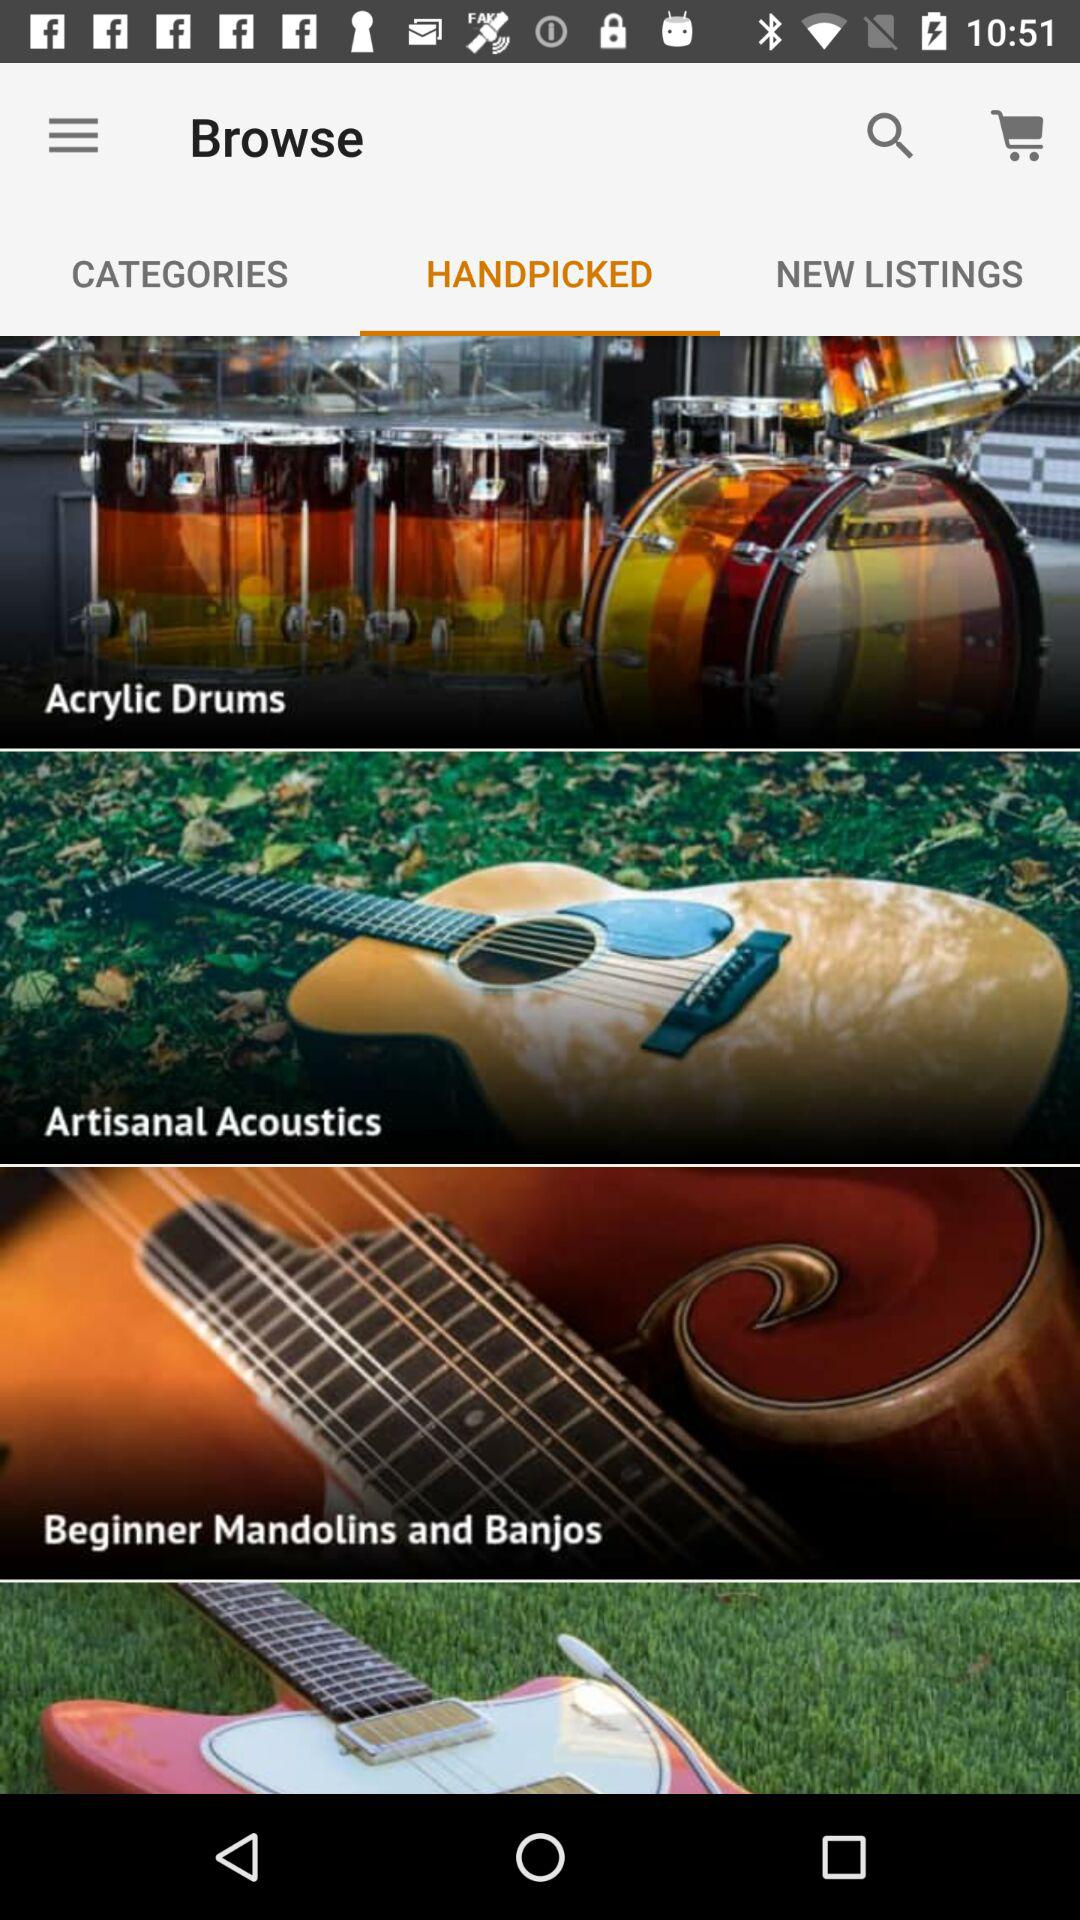What are the categories?
When the provided information is insufficient, respond with <no answer>. <no answer> 